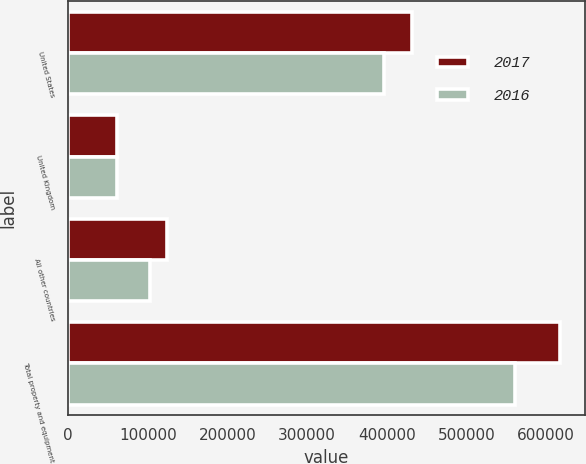<chart> <loc_0><loc_0><loc_500><loc_500><stacked_bar_chart><ecel><fcel>United States<fcel>United Kingdom<fcel>All other countries<fcel>Total property and equipment<nl><fcel>2017<fcel>432102<fcel>61335<fcel>124302<fcel>617739<nl><fcel>2016<fcel>396608<fcel>61327<fcel>102821<fcel>560756<nl></chart> 